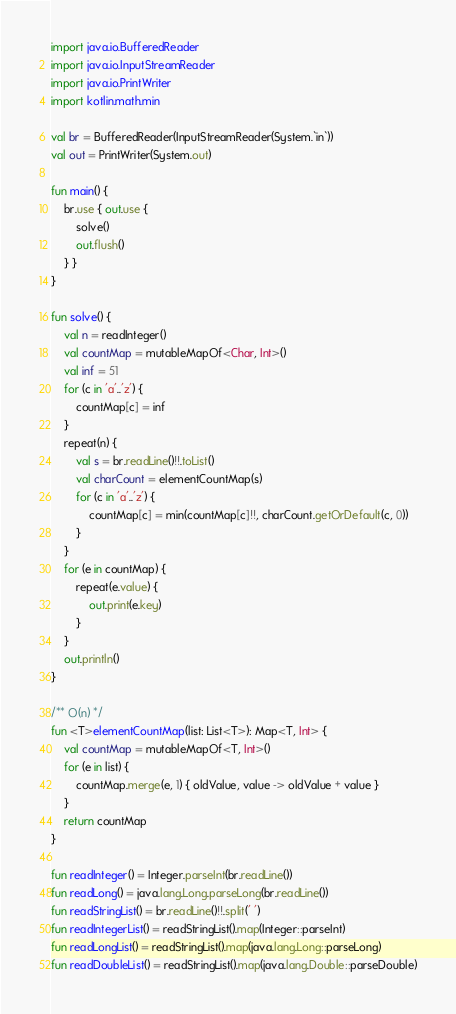Convert code to text. <code><loc_0><loc_0><loc_500><loc_500><_Kotlin_>import java.io.BufferedReader
import java.io.InputStreamReader
import java.io.PrintWriter
import kotlin.math.min

val br = BufferedReader(InputStreamReader(System.`in`))
val out = PrintWriter(System.out)

fun main() {
    br.use { out.use {
        solve()
        out.flush()
    } }
}

fun solve() {
    val n = readInteger()
    val countMap = mutableMapOf<Char, Int>()
    val inf = 51
    for (c in 'a'..'z') {
        countMap[c] = inf
    }
    repeat(n) {
        val s = br.readLine()!!.toList()
        val charCount = elementCountMap(s)
        for (c in 'a'..'z') {
            countMap[c] = min(countMap[c]!!, charCount.getOrDefault(c, 0))
        }
    }
    for (e in countMap) {
        repeat(e.value) {
            out.print(e.key)
        }
    }
    out.println()
}

/** O(n) */
fun <T>elementCountMap(list: List<T>): Map<T, Int> {
    val countMap = mutableMapOf<T, Int>()
    for (e in list) {
        countMap.merge(e, 1) { oldValue, value -> oldValue + value }
    }
    return countMap
}

fun readInteger() = Integer.parseInt(br.readLine())
fun readLong() = java.lang.Long.parseLong(br.readLine())
fun readStringList() = br.readLine()!!.split(' ')
fun readIntegerList() = readStringList().map(Integer::parseInt)
fun readLongList() = readStringList().map(java.lang.Long::parseLong)
fun readDoubleList() = readStringList().map(java.lang.Double::parseDouble)
</code> 